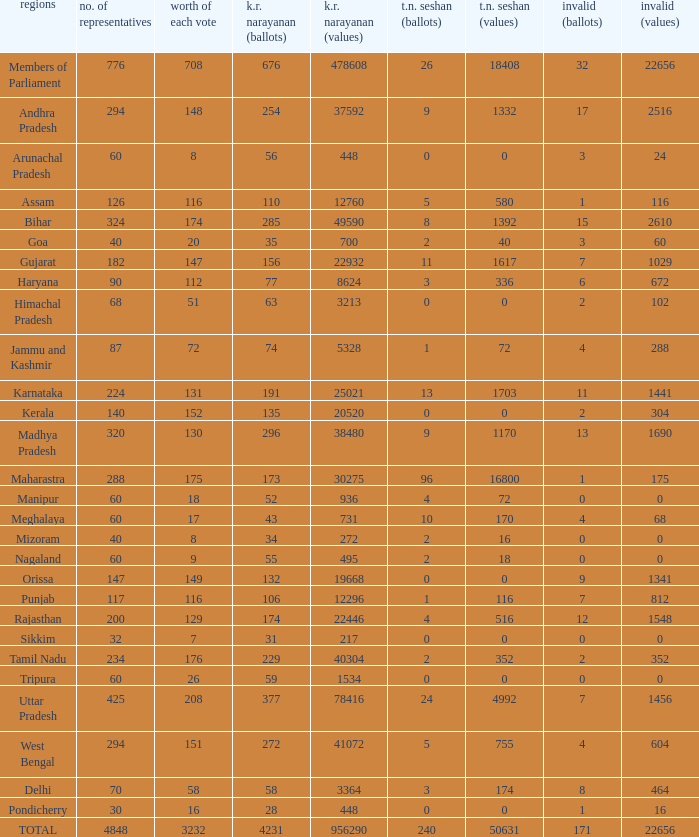Name the number of tn seshan values for kr values is 478608 1.0. 